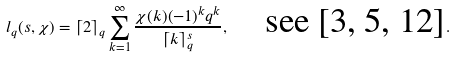<formula> <loc_0><loc_0><loc_500><loc_500>l _ { q } ( s , \chi ) = \lceil 2 \rceil _ { q } \sum _ { k = 1 } ^ { \infty } \frac { \chi ( k ) ( - 1 ) ^ { k } q ^ { k } } { \lceil k \rceil _ { q } ^ { s } } , \quad \text {see [3, 5, 12]} .</formula> 